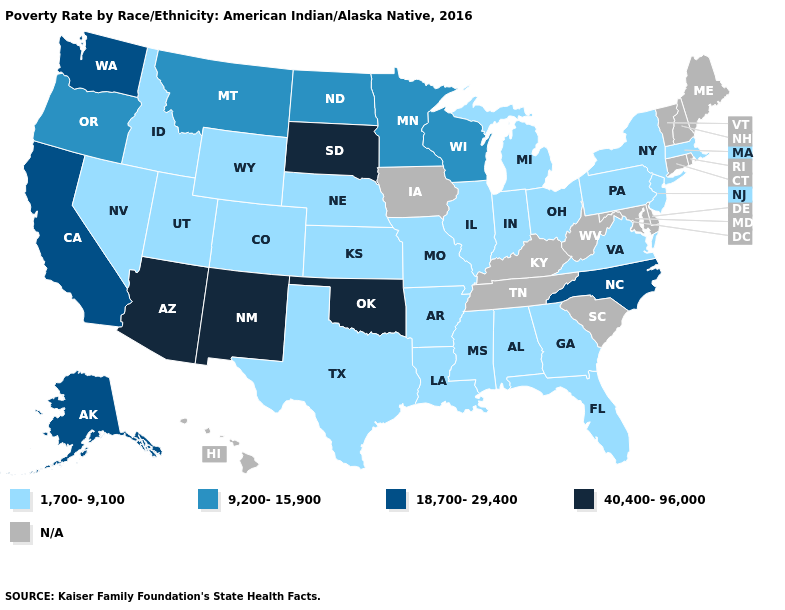Among the states that border Oregon , does Washington have the highest value?
Be succinct. Yes. What is the value of Illinois?
Answer briefly. 1,700-9,100. Does New Mexico have the highest value in the USA?
Concise answer only. Yes. What is the highest value in the USA?
Concise answer only. 40,400-96,000. Name the states that have a value in the range N/A?
Short answer required. Connecticut, Delaware, Hawaii, Iowa, Kentucky, Maine, Maryland, New Hampshire, Rhode Island, South Carolina, Tennessee, Vermont, West Virginia. What is the value of Arkansas?
Quick response, please. 1,700-9,100. Does the map have missing data?
Give a very brief answer. Yes. Which states hav the highest value in the West?
Be succinct. Arizona, New Mexico. Name the states that have a value in the range 40,400-96,000?
Quick response, please. Arizona, New Mexico, Oklahoma, South Dakota. Name the states that have a value in the range N/A?
Give a very brief answer. Connecticut, Delaware, Hawaii, Iowa, Kentucky, Maine, Maryland, New Hampshire, Rhode Island, South Carolina, Tennessee, Vermont, West Virginia. What is the value of Illinois?
Give a very brief answer. 1,700-9,100. Which states have the lowest value in the MidWest?
Keep it brief. Illinois, Indiana, Kansas, Michigan, Missouri, Nebraska, Ohio. Does Minnesota have the lowest value in the MidWest?
Short answer required. No. 